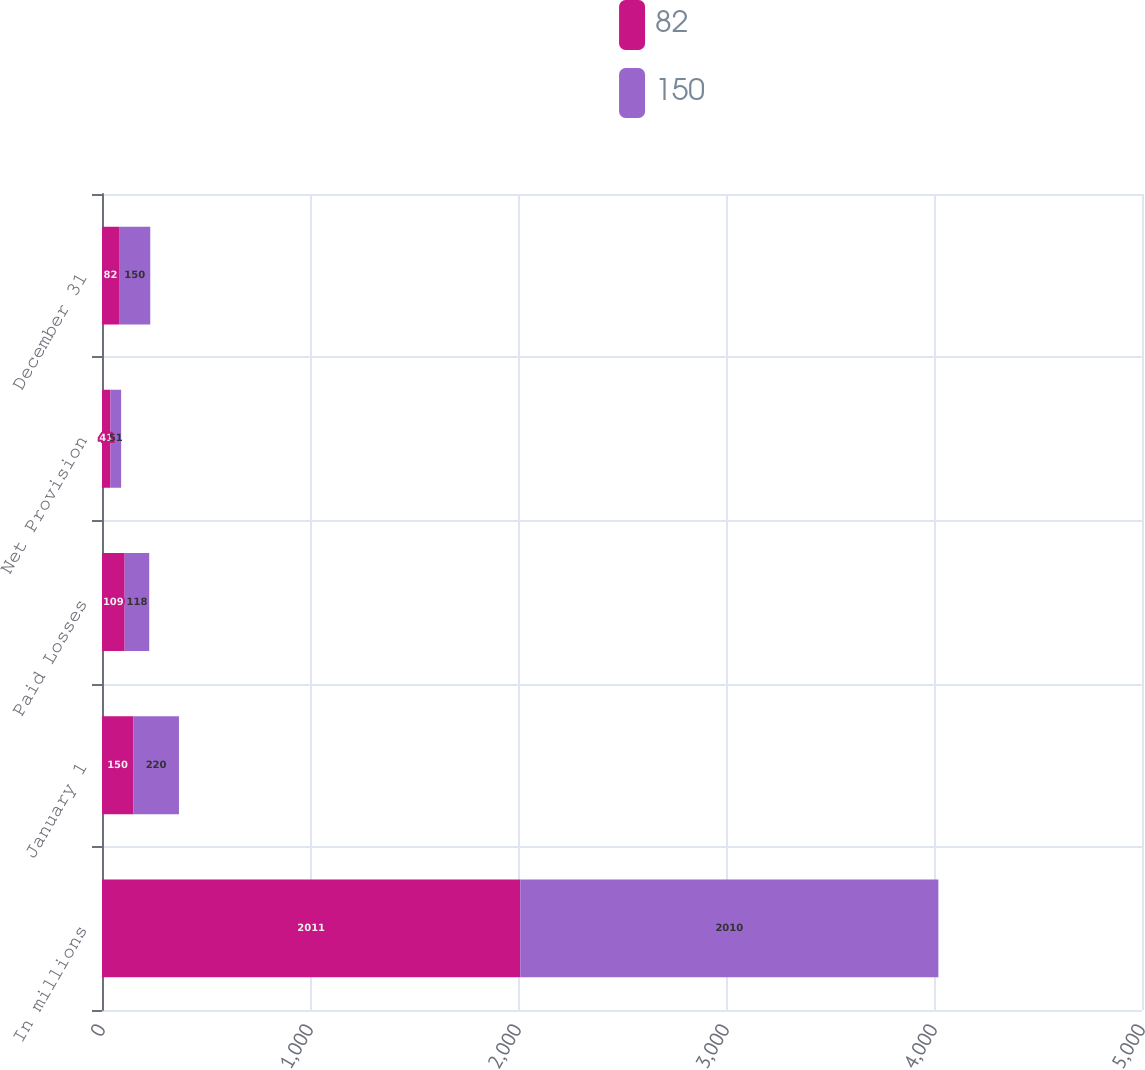Convert chart to OTSL. <chart><loc_0><loc_0><loc_500><loc_500><stacked_bar_chart><ecel><fcel>In millions<fcel>January 1<fcel>Paid Losses<fcel>Net Provision<fcel>December 31<nl><fcel>82<fcel>2011<fcel>150<fcel>109<fcel>41<fcel>82<nl><fcel>150<fcel>2010<fcel>220<fcel>118<fcel>51<fcel>150<nl></chart> 